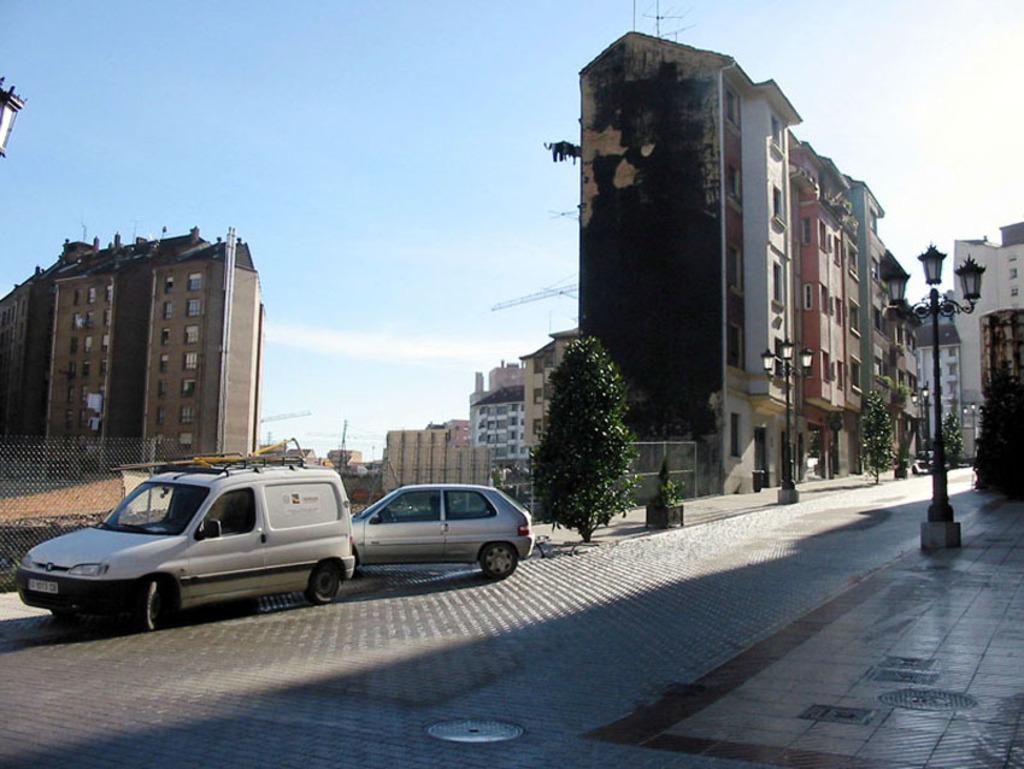Can you describe this image briefly? This is the picture of a place where we have some buildings to which there are some windows and around there are some trees, cars and some poles. 